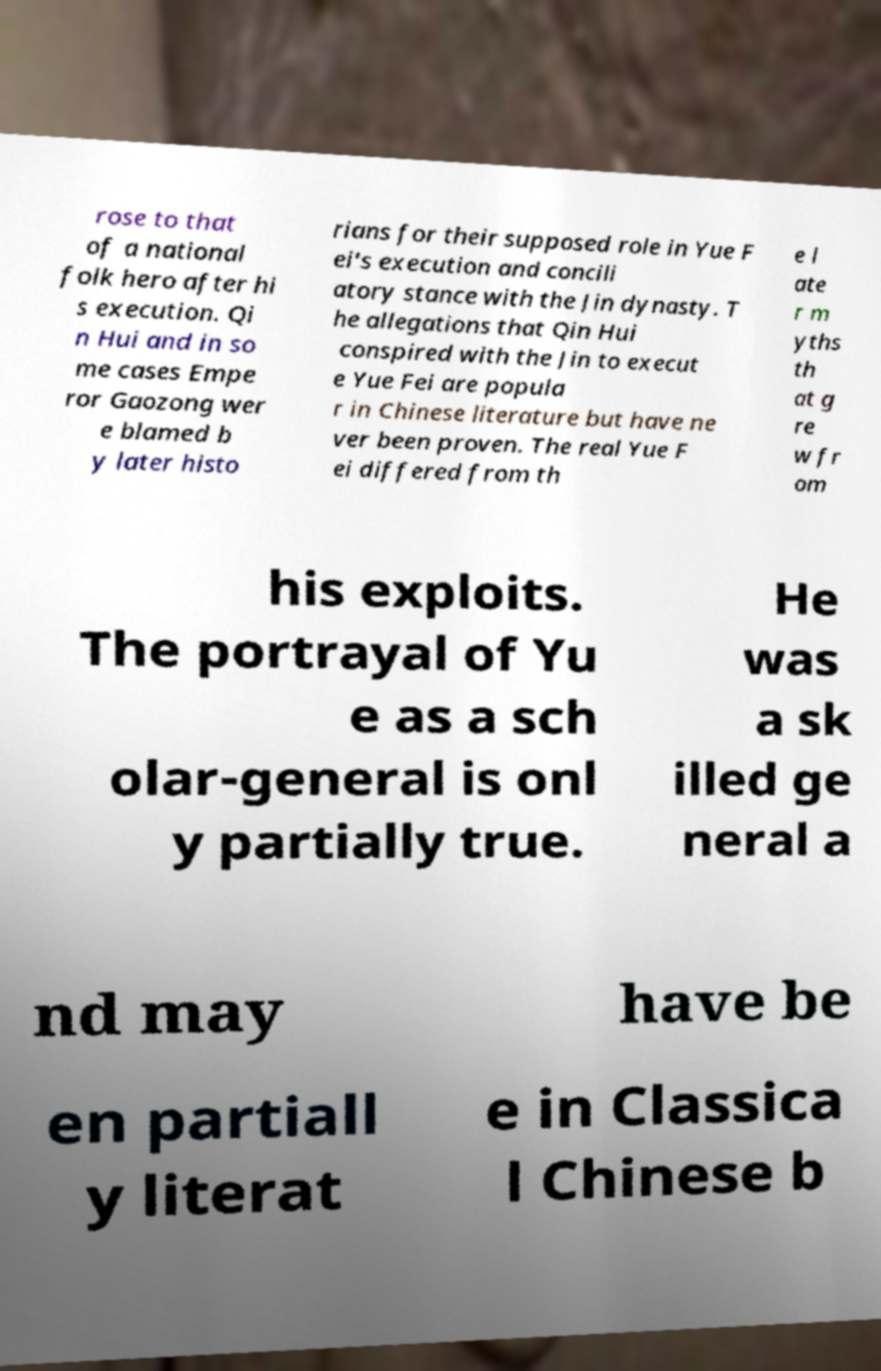There's text embedded in this image that I need extracted. Can you transcribe it verbatim? rose to that of a national folk hero after hi s execution. Qi n Hui and in so me cases Empe ror Gaozong wer e blamed b y later histo rians for their supposed role in Yue F ei's execution and concili atory stance with the Jin dynasty. T he allegations that Qin Hui conspired with the Jin to execut e Yue Fei are popula r in Chinese literature but have ne ver been proven. The real Yue F ei differed from th e l ate r m yths th at g re w fr om his exploits. The portrayal of Yu e as a sch olar-general is onl y partially true. He was a sk illed ge neral a nd may have be en partiall y literat e in Classica l Chinese b 